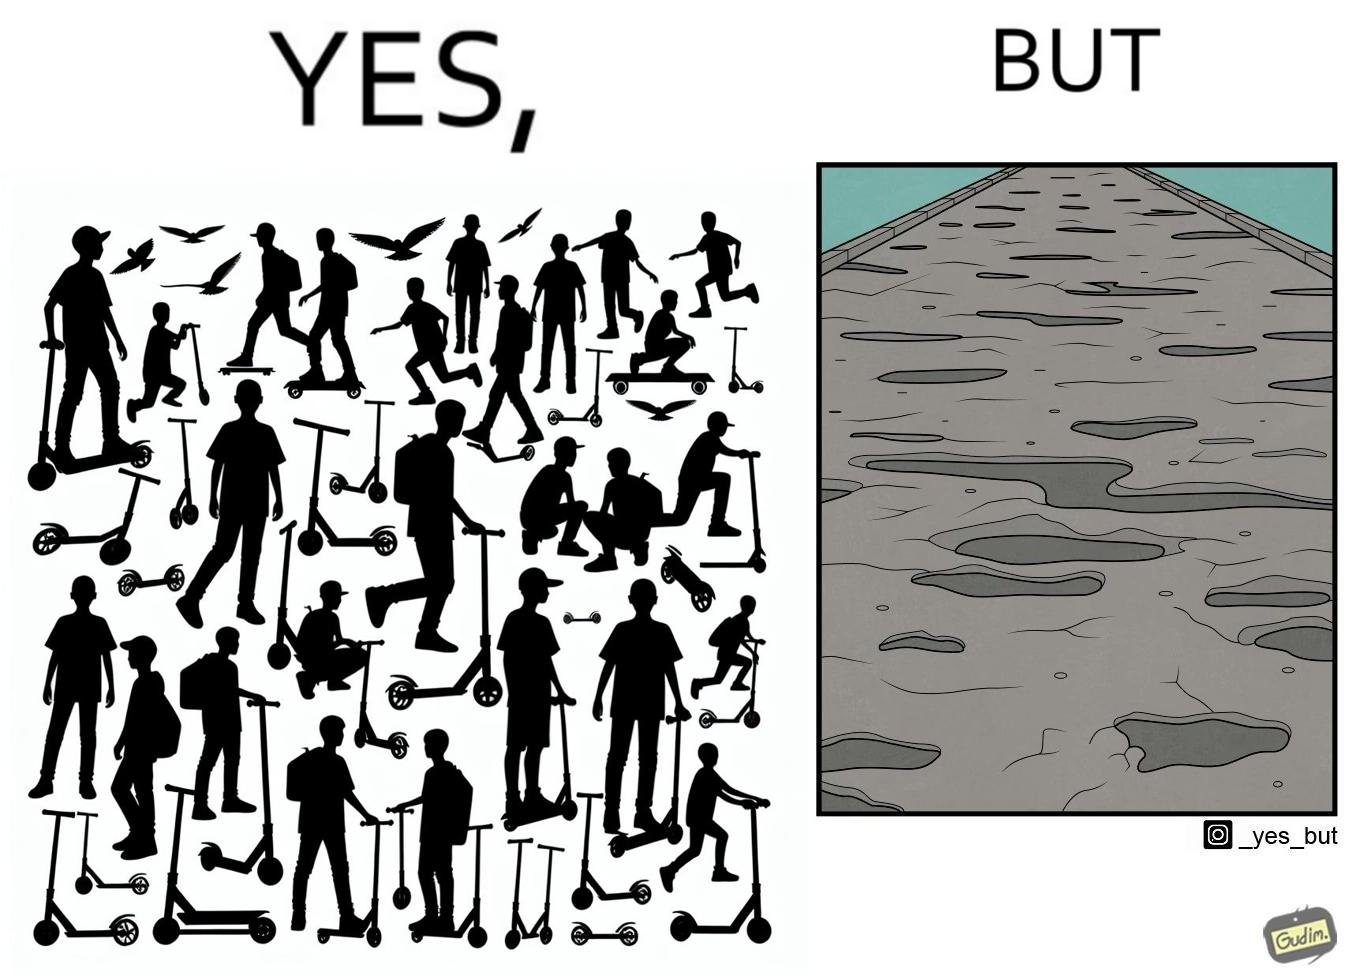Describe what you see in this image. The image is ironic, because even after when the skateboard scooters are available for someone to ride but the road has many potholes that it is not suitable to ride the scooters on such roads 